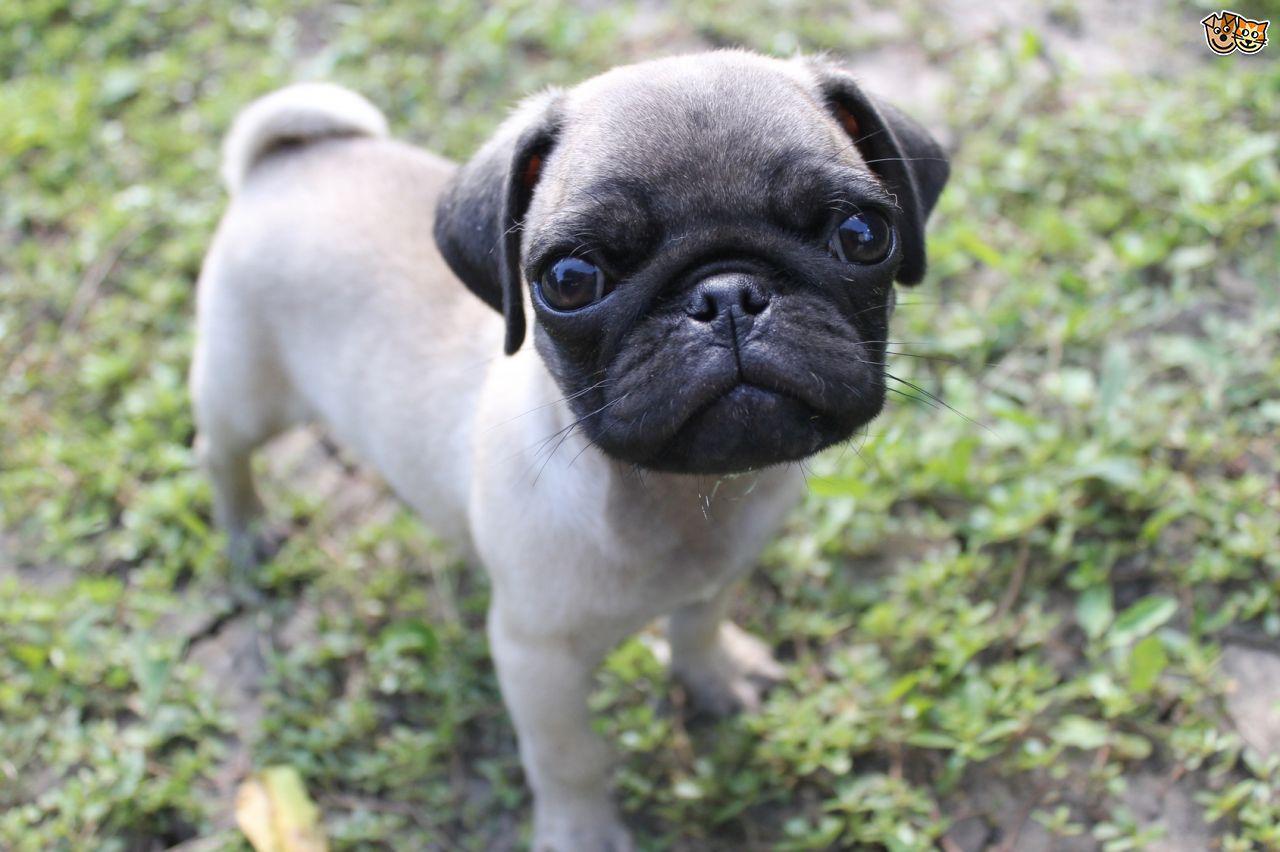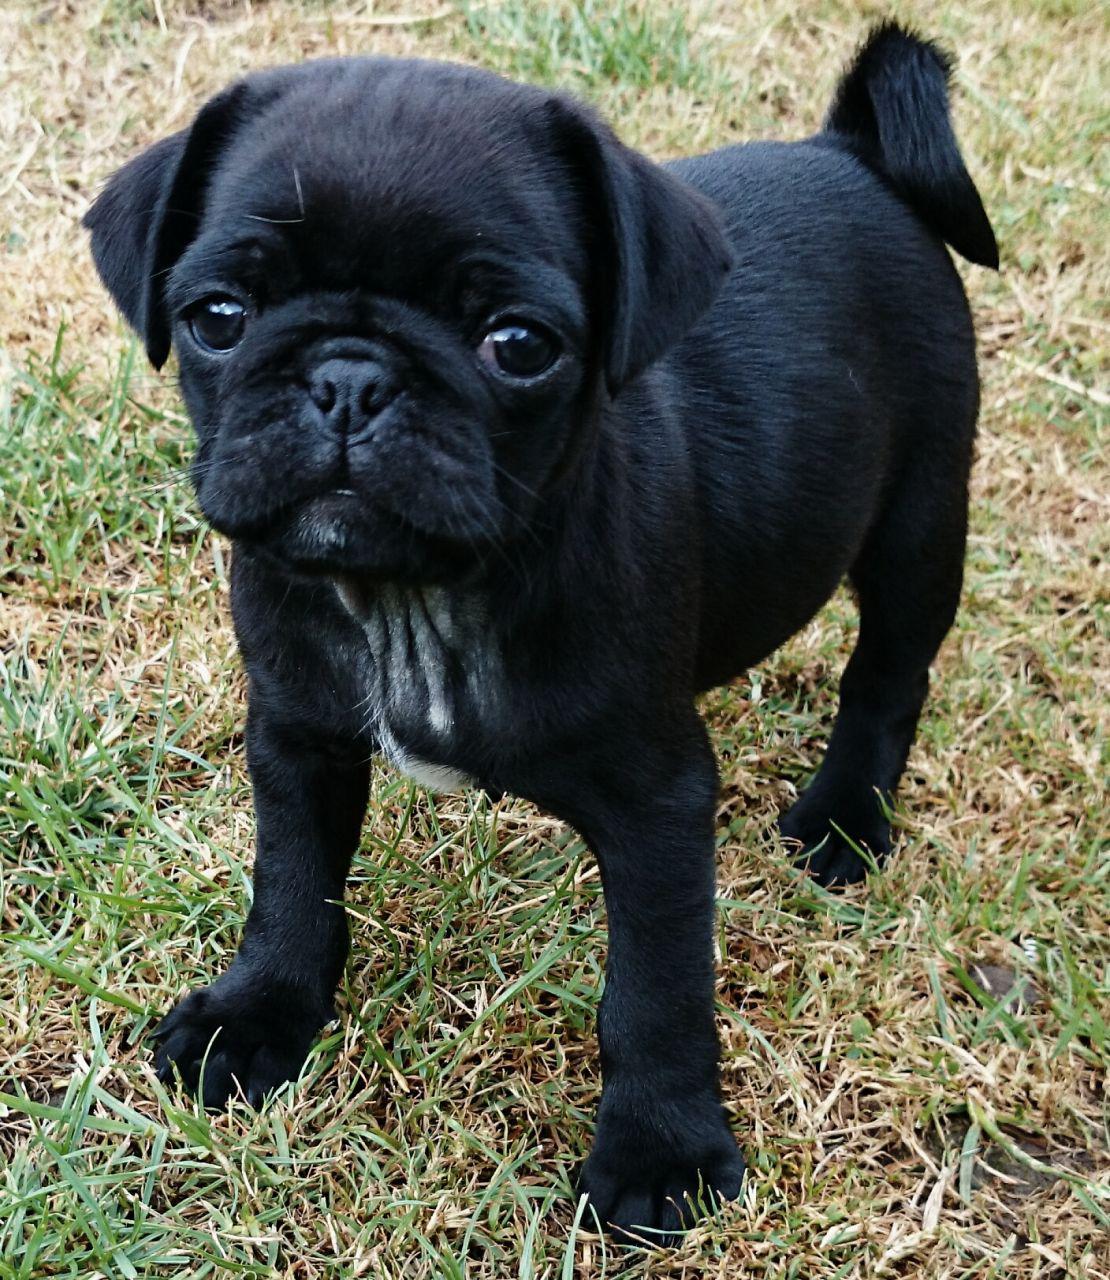The first image is the image on the left, the second image is the image on the right. Analyze the images presented: Is the assertion "There is a single black dog looking at the camera." valid? Answer yes or no. Yes. The first image is the image on the left, the second image is the image on the right. Considering the images on both sides, is "We've got three pups here." valid? Answer yes or no. No. 